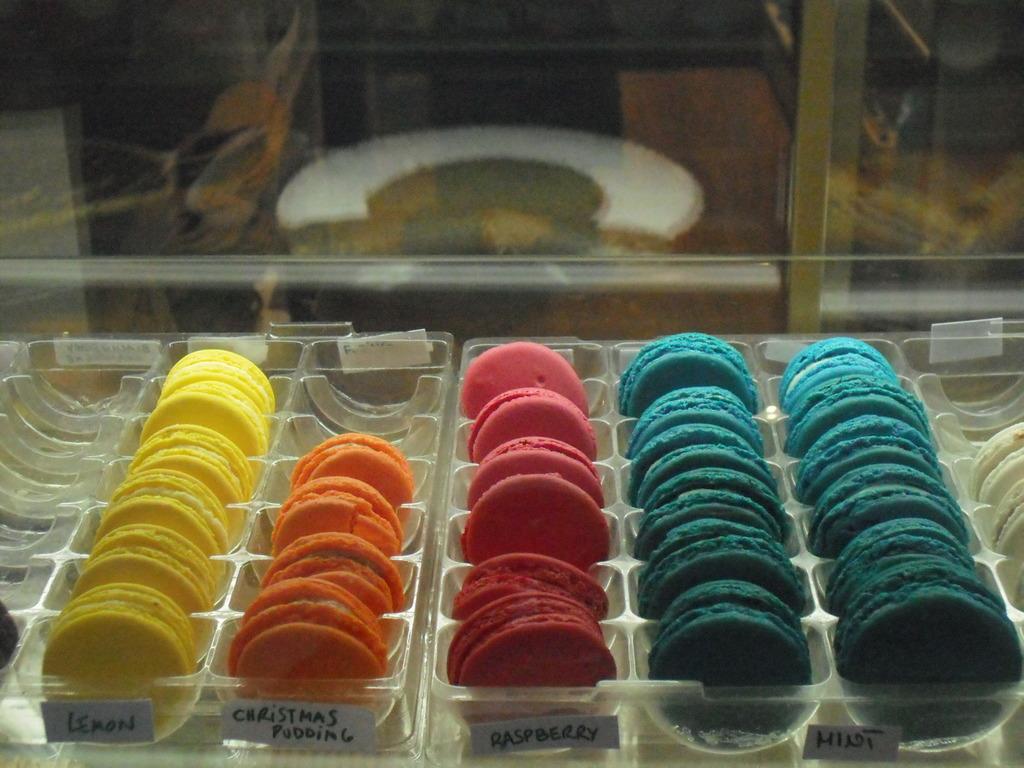What flavor are the yellow cookies?
Your answer should be compact. Lemon. 